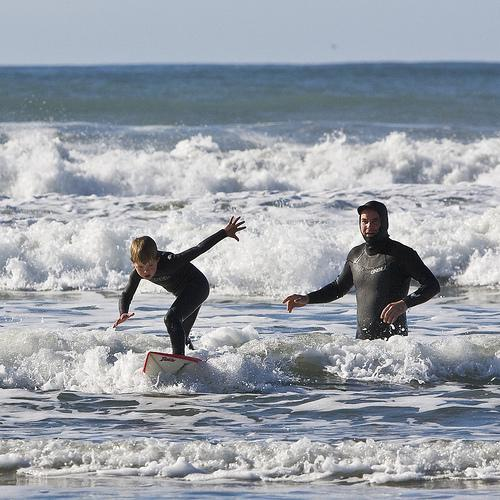Question: who is not on a surfboard?
Choices:
A. The man.
B. The woman.
C. The girl.
D. The boy.
Answer with the letter. Answer: A Question: what color are the wetsuits?
Choices:
A. Purple.
B. Red.
C. Black.
D. Yellow.
Answer with the letter. Answer: C Question: what are the two people wearing?
Choices:
A. Wetsuits.
B. Swim suits.
C. Nothing.
D. Clothing.
Answer with the letter. Answer: A Question: why is the boy standing?
Choices:
A. He is waiting.
B. He is surfing.
C. He is riding a skateboard.
D. He is wave boarding.
Answer with the letter. Answer: B Question: where is the surfboard?
Choices:
A. In the sand.
B. In their hand.
C. On the water.
D. In the car.
Answer with the letter. Answer: C Question: what is carrying the surfboard?
Choices:
A. A man.
B. A woman.
C. The current.
D. Wave.
Answer with the letter. Answer: D 